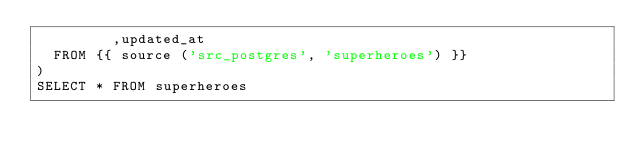<code> <loc_0><loc_0><loc_500><loc_500><_SQL_>	       ,updated_at
	FROM {{ source ('src_postgres', 'superheroes') }}
)
SELECT * FROM superheroes
</code> 